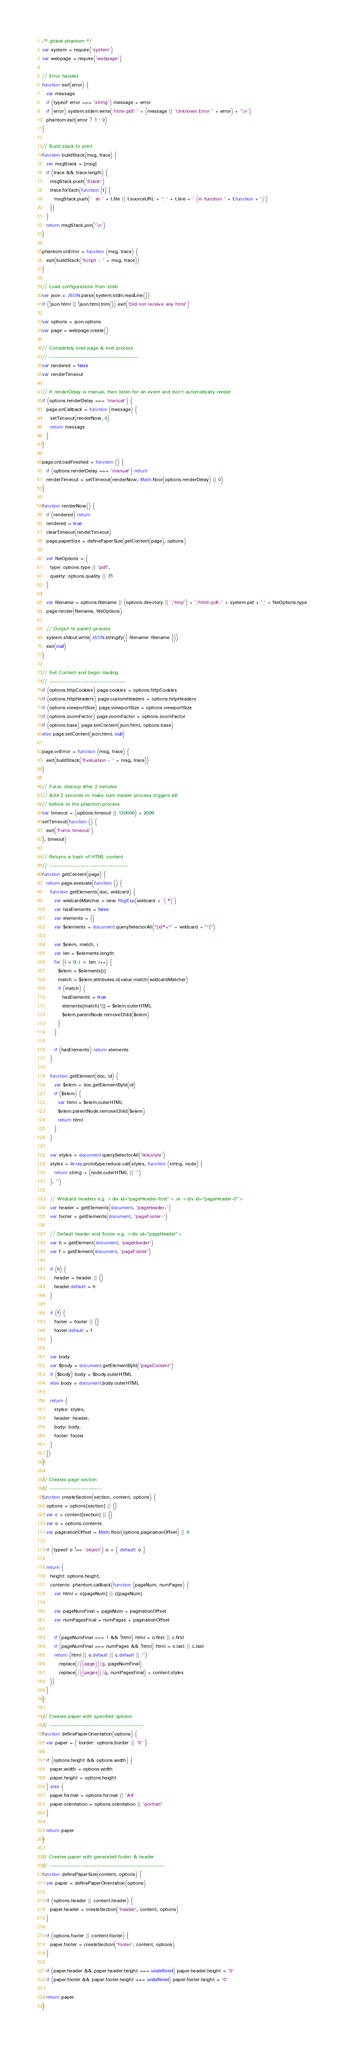Convert code to text. <code><loc_0><loc_0><loc_500><loc_500><_JavaScript_>/* global phantom */
var system = require('system')
var webpage = require('webpage')

// Error handler
function exit(error) {
  var message
  if (typeof error === 'string') message = error
  if (error) system.stderr.write('html-pdf: ' + (message || 'Unknown Error ' + error) + '\n')
  phantom.exit(error ? 1 : 0)
}

// Build stack to print
function buildStack(msg, trace) {
  var msgStack = [msg]
  if (trace && trace.length) {
    msgStack.push('Stack:')
    trace.forEach(function (t) {
      msgStack.push('  at ' + t.file || t.sourceURL + ': ' + t.line + ' (in function ' + t.function + ')')
    })
  }
  return msgStack.join('\n')
}

phantom.onError = function (msg, trace) {
  exit(buildStack('Script - ' + msg, trace))
}

// Load configurations from stdin
var json = JSON.parse(system.stdin.readLine())
if (!json.html || !json.html.trim()) exit('Did not receive any html')

var options = json.options
var page = webpage.create()

// Completely load page & end process
// ----------------------------------
var rendered = false
var renderTimeout

// If renderDelay is manual, then listen for an event and don't automatically render
if (options.renderDelay === 'manual') {
  page.onCallback = function (message) {
    setTimeout(renderNow, 0)
    return message
  }
}

page.onLoadFinished = function () {
  if (options.renderDelay === 'manual') return
  renderTimeout = setTimeout(renderNow, Math.floor(options.renderDelay) || 0)
}

function renderNow() {
  if (rendered) return
  rendered = true
  clearTimeout(renderTimeout)
  page.paperSize = definePaperSize(getContent(page), options)

  var fileOptions = {
    type: options.type || 'pdf',
    quality: options.quality || 75
  }

  var filename = options.filename || (options.directory || '/tmp') + '/html-pdf-' + system.pid + '.' + fileOptions.type
  page.render(filename, fileOptions)

  // Output to parent process
  system.stdout.write(JSON.stringify({ filename: filename }))
  exit(null)
}

// Set Content and begin loading
// -----------------------------
if (options.httpCookies) page.cookies = options.httpCookies
if (options.httpHeaders) page.customHeaders = options.httpHeaders
if (options.viewportSize) page.viewportSize = options.viewportSize
if (options.zoomFactor) page.zoomFactor = options.zoomFactor
if (options.base) page.setContent(json.html, options.base)
else page.setContent(json.html, null)

page.onError = function (msg, trace) {
  exit(buildStack('Evaluation - ' + msg, trace))
}

// Force cleanup after 2 minutes
// Add 2 seconds to make sure master process triggers kill
// before to the phantom process
var timeout = (options.timeout || 120000) + 2000
setTimeout(function () {
  exit('Force timeout')
}, timeout)

// Returns a hash of HTML content
// ------------------------------
function getContent(page) {
  return page.evaluate(function () {
    function getElements(doc, wildcard) {
      var wildcardMatcher = new RegExp(wildcard + '(.*)')
      var hasElements = false
      var elements = {}
      var $elements = document.querySelectorAll("[id*='" + wildcard + "']")

      var $elem, match, i
      var len = $elements.length
      for (i = 0; i < len; i++) {
        $elem = $elements[i]
        match = $elem.attributes.id.value.match(wildcardMatcher)
        if (match) {
          hasElements = true
          elements[match[1]] = $elem.outerHTML
          $elem.parentNode.removeChild($elem)
        }
      }

      if (hasElements) return elements
    }

    function getElement(doc, id) {
      var $elem = doc.getElementById(id)
      if ($elem) {
        var html = $elem.outerHTML
        $elem.parentNode.removeChild($elem)
        return html
      }
    }

    var styles = document.querySelectorAll('link,style')
    styles = Array.prototype.reduce.call(styles, function (string, node) {
      return string + (node.outerHTML || '')
    }, '')

    // Wildcard headers e.g. <div id="pageHeader-first"> or <div id="pageHeader-0">
    var header = getElements(document, 'pageHeader-')
    var footer = getElements(document, 'pageFooter-')

    // Default header and footer e.g. <div id="pageHeader">
    var h = getElement(document, 'pageHeader')
    var f = getElement(document, 'pageFooter')

    if (h) {
      header = header || {}
      header.default = h
    }

    if (f) {
      footer = footer || {}
      footer.default = f
    }

    var body
    var $body = document.getElementById('pageContent')
    if ($body) body = $body.outerHTML
    else body = document.body.outerHTML

    return {
      styles: styles,
      header: header,
      body: body,
      footer: footer
    }
  })
}

// Creates page section
// --------------------
function createSection(section, content, options) {
  options = options[section] || {}
  var c = content[section] || {}
  var o = options.contents
  var paginationOffset = Math.floor(options.paginationOffset) || 0

  if (typeof o !== 'object') o = { default: o }

  return {
    height: options.height,
    contents: phantom.callback(function (pageNum, numPages) {
      var html = o[pageNum] || c[pageNum]

      var pageNumFinal = pageNum + paginationOffset
      var numPagesFinal = numPages + paginationOffset

      if (pageNumFinal === 1 && !html) html = o.first || c.first
      if (pageNumFinal === numPages && !html) html = o.last || c.last
      return (html || o.default || c.default || '')
        .replace(/{{page}}/g, pageNumFinal)
        .replace(/{{pages}}/g, numPagesFinal) + content.styles
    })
  }
}

// Creates paper with specified options
// ------------------------------------
function definePaperOrientation(options) {
  var paper = { border: options.border || '0' }

  if (options.height && options.width) {
    paper.width = options.width
    paper.height = options.height
  } else {
    paper.format = options.format || 'A4'
    paper.orientation = options.orientation || 'portrait'
  }

  return paper
}

// Creates paper with generated footer & header
// --------------------------------------------
function definePaperSize(content, options) {
  var paper = definePaperOrientation(options)

  if (options.header || content.header) {
    paper.header = createSection('header', content, options)
  }

  if (options.footer || content.footer) {
    paper.footer = createSection('footer', content, options)
  }

  if (paper.header && paper.header.height === undefined) paper.header.height = '0'
  if (paper.footer && paper.footer.height === undefined) paper.footer.height = '0'

  return paper
}
</code> 